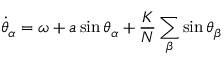Convert formula to latex. <formula><loc_0><loc_0><loc_500><loc_500>\dot { \theta } _ { \alpha } = \omega + a \sin \theta _ { \alpha } + \frac { K } { N } \sum _ { \beta } \sin \theta _ { \beta }</formula> 